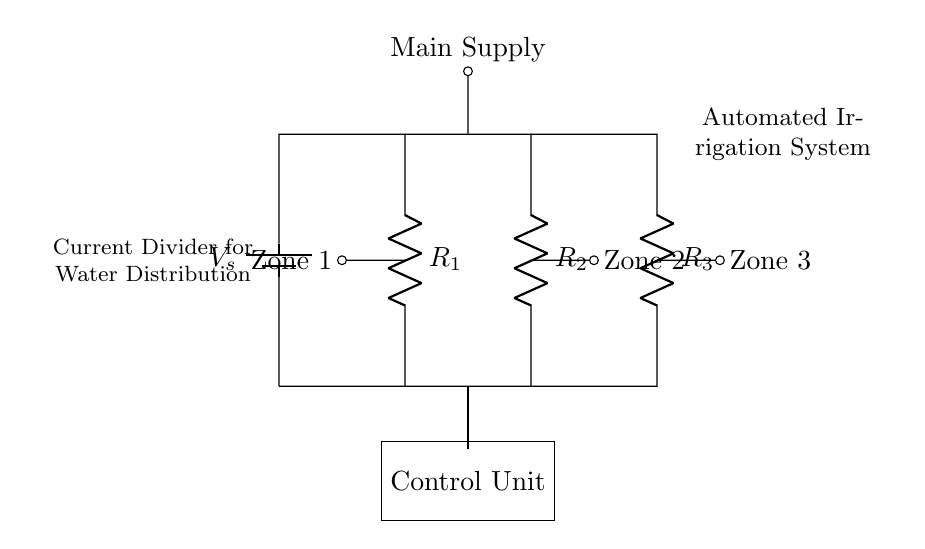What is the voltage source in the circuit? The voltage source is marked as V_s, which is supplying electrical energy to the circuit.
Answer: V_s How many resistors are in parallel in this circuit? There are three resistors, R_1, R_2, and R_3, connected in parallel since they share the same two nodes at the top and bottom.
Answer: 3 What is the function of the control unit in the circuit? The control unit regulates the distribution of current to the different zones, allowing for automated irrigation control based on water distribution demand.
Answer: Regulate Which zone is closest to the main supply? Zone 1 is closest to the main supply, as it is connected directly to the main supply line in the diagram.
Answer: Zone 1 What principle is applied to distribute the current among the resistors? The current divider principle is applied, which states that the current flowing through each resistor in parallel is inversely proportional to its resistance.
Answer: Current divider Which resistor has the highest current flowing through it? The resistor with the lowest resistance value will have the highest current, according to the current divider principle; thus, without specific resistance values, we cannot definitively answer.
Answer: Not determinable 